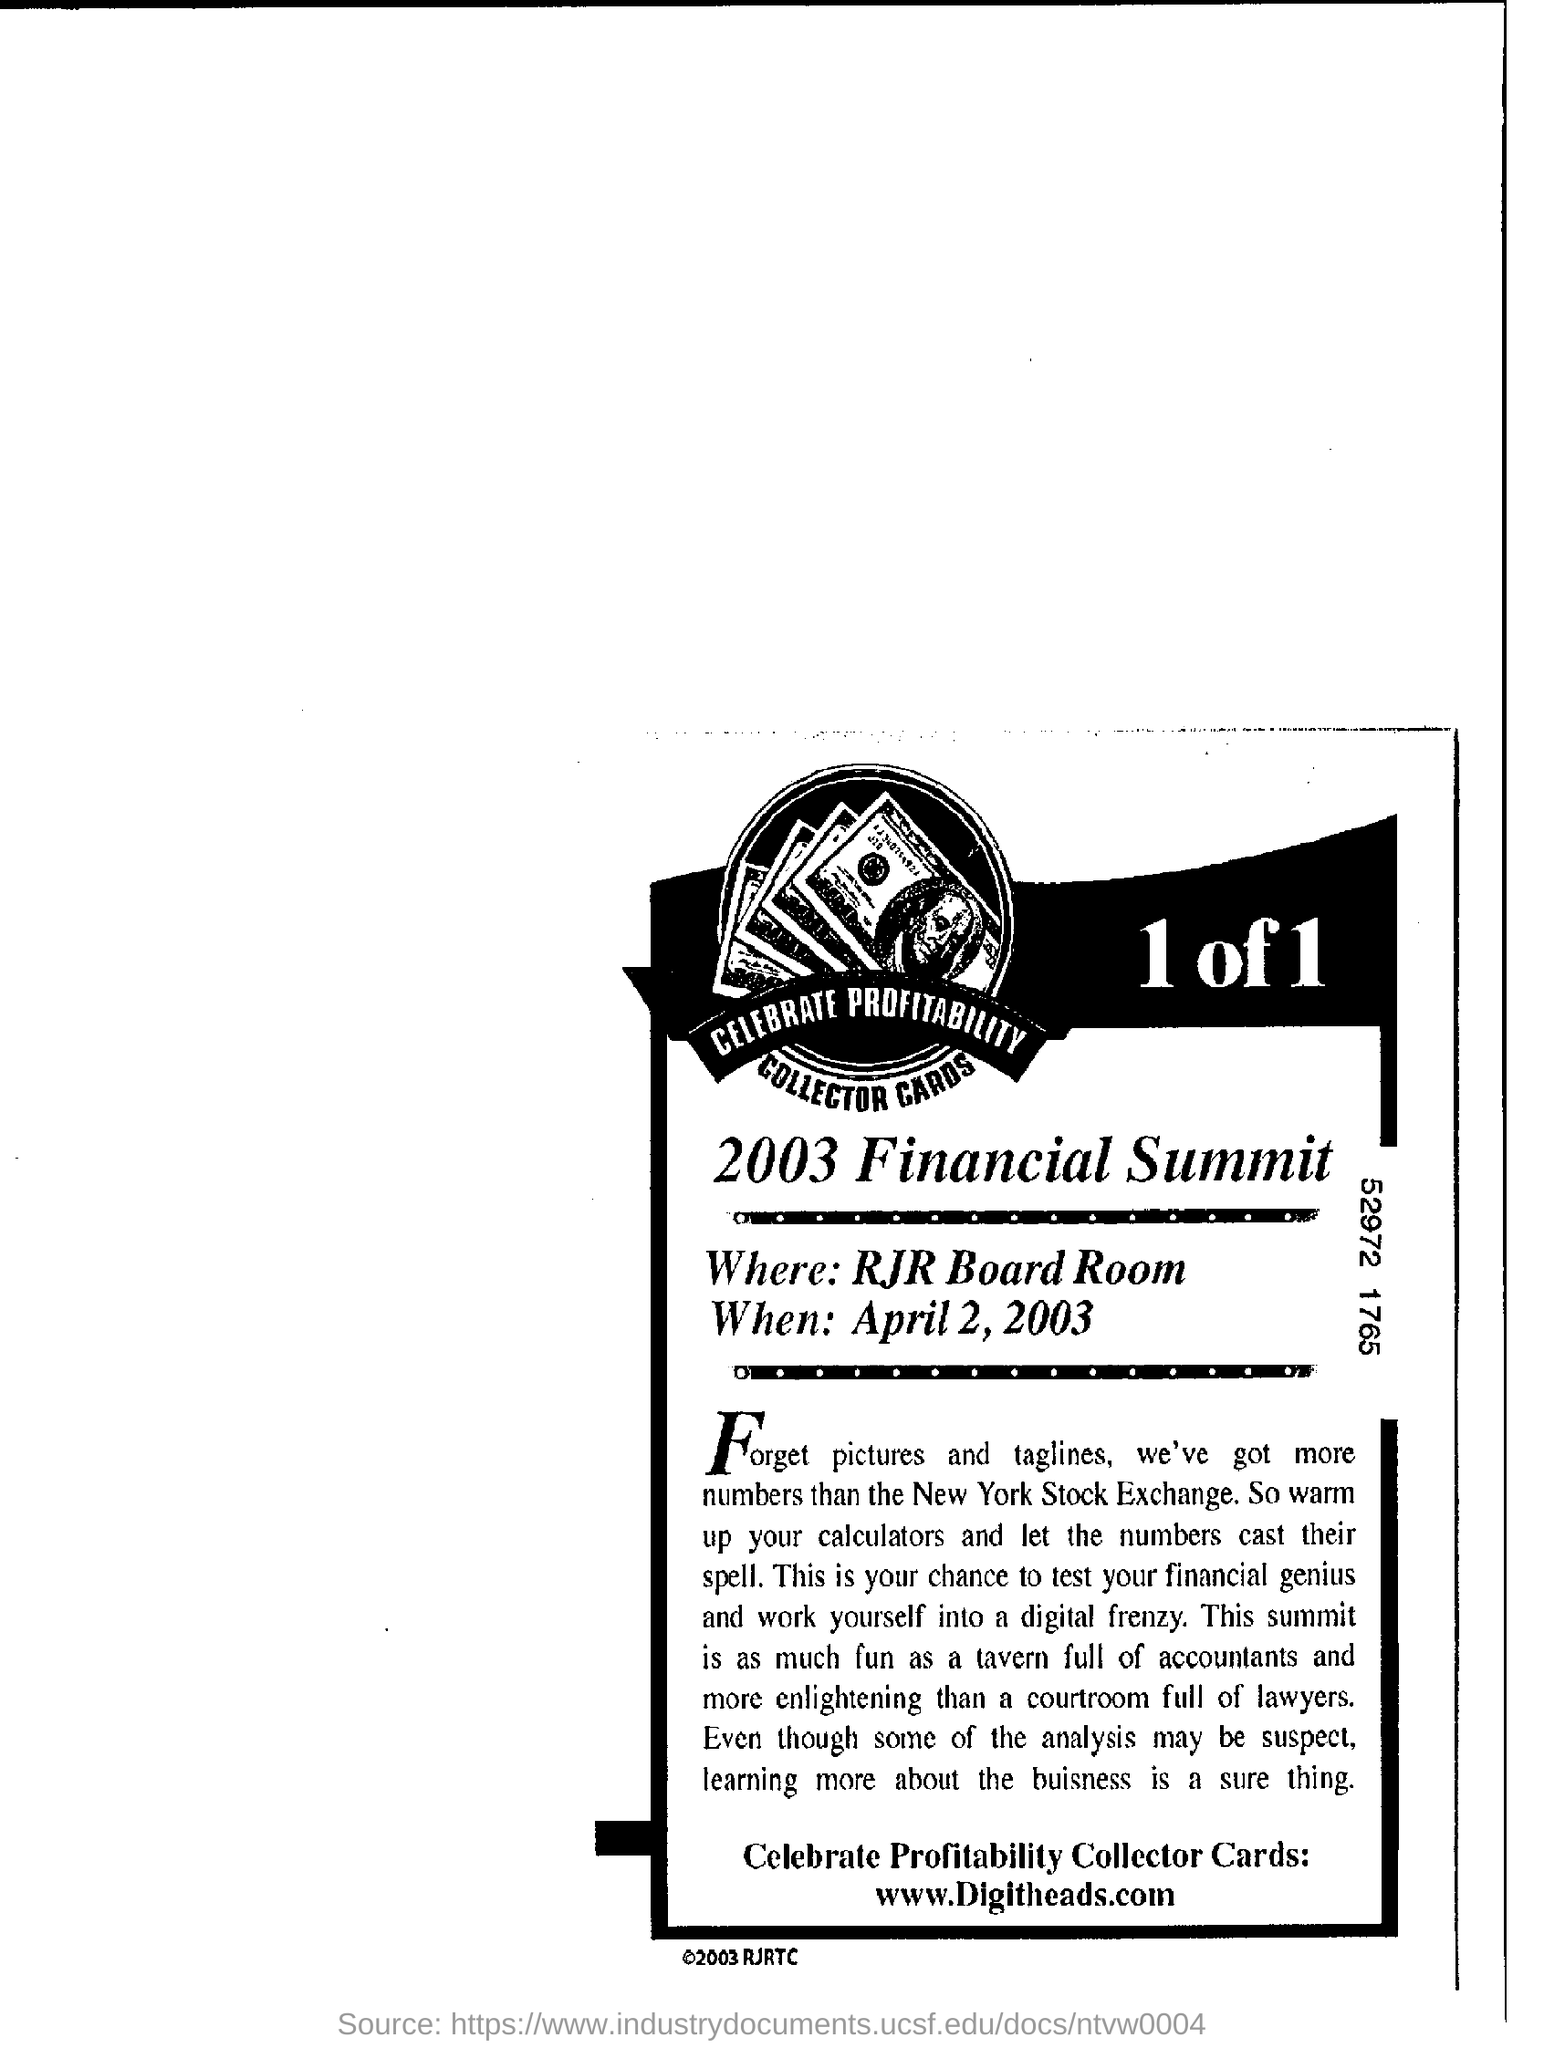What is the name of the summit ?
Your answer should be very brief. 2003 Financial Summit. Where is the summit ?
Make the answer very short. RJR Board Room. When is the summit ?
Your response must be concise. April 2, 2003. What is the website address mentioned at the bottom?
Make the answer very short. Www.digitheads.com. 